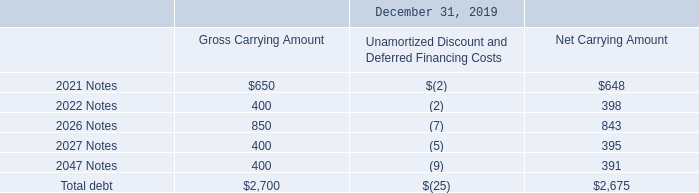Debt
At both December 31, 2019 and December 31, 2018, our total outstanding debt was $2.7 billion, bearing interest at a weighted average rate of 3.18%.
A summary of our outstanding debt as of December 31, 2019, is as follows (amounts in millions):
What was the company's outstanding debt At both December 31, 2019 and December 31, 2018?
Answer scale should be: billion. $2.7 billion. What was the gross carrying amount in the 2021 Notes?
Answer scale should be: million. $650. What was the gross carrying amount in the 2022 Notes?
Answer scale should be: million. 400. What was the change in gross carrying amount between the 2021 and 2022 Notes?
Answer scale should be: million. (650-400)
Answer: 250. What is the sum of the 2 highest gross carrying amounts?
Answer scale should be: million. (850+650)
Answer: 1500. What is the percentage change in the net carrying amount between the 2022 Notes and 2026 Notes?
Answer scale should be: percent. (843-398)/398
Answer: 111.81. 